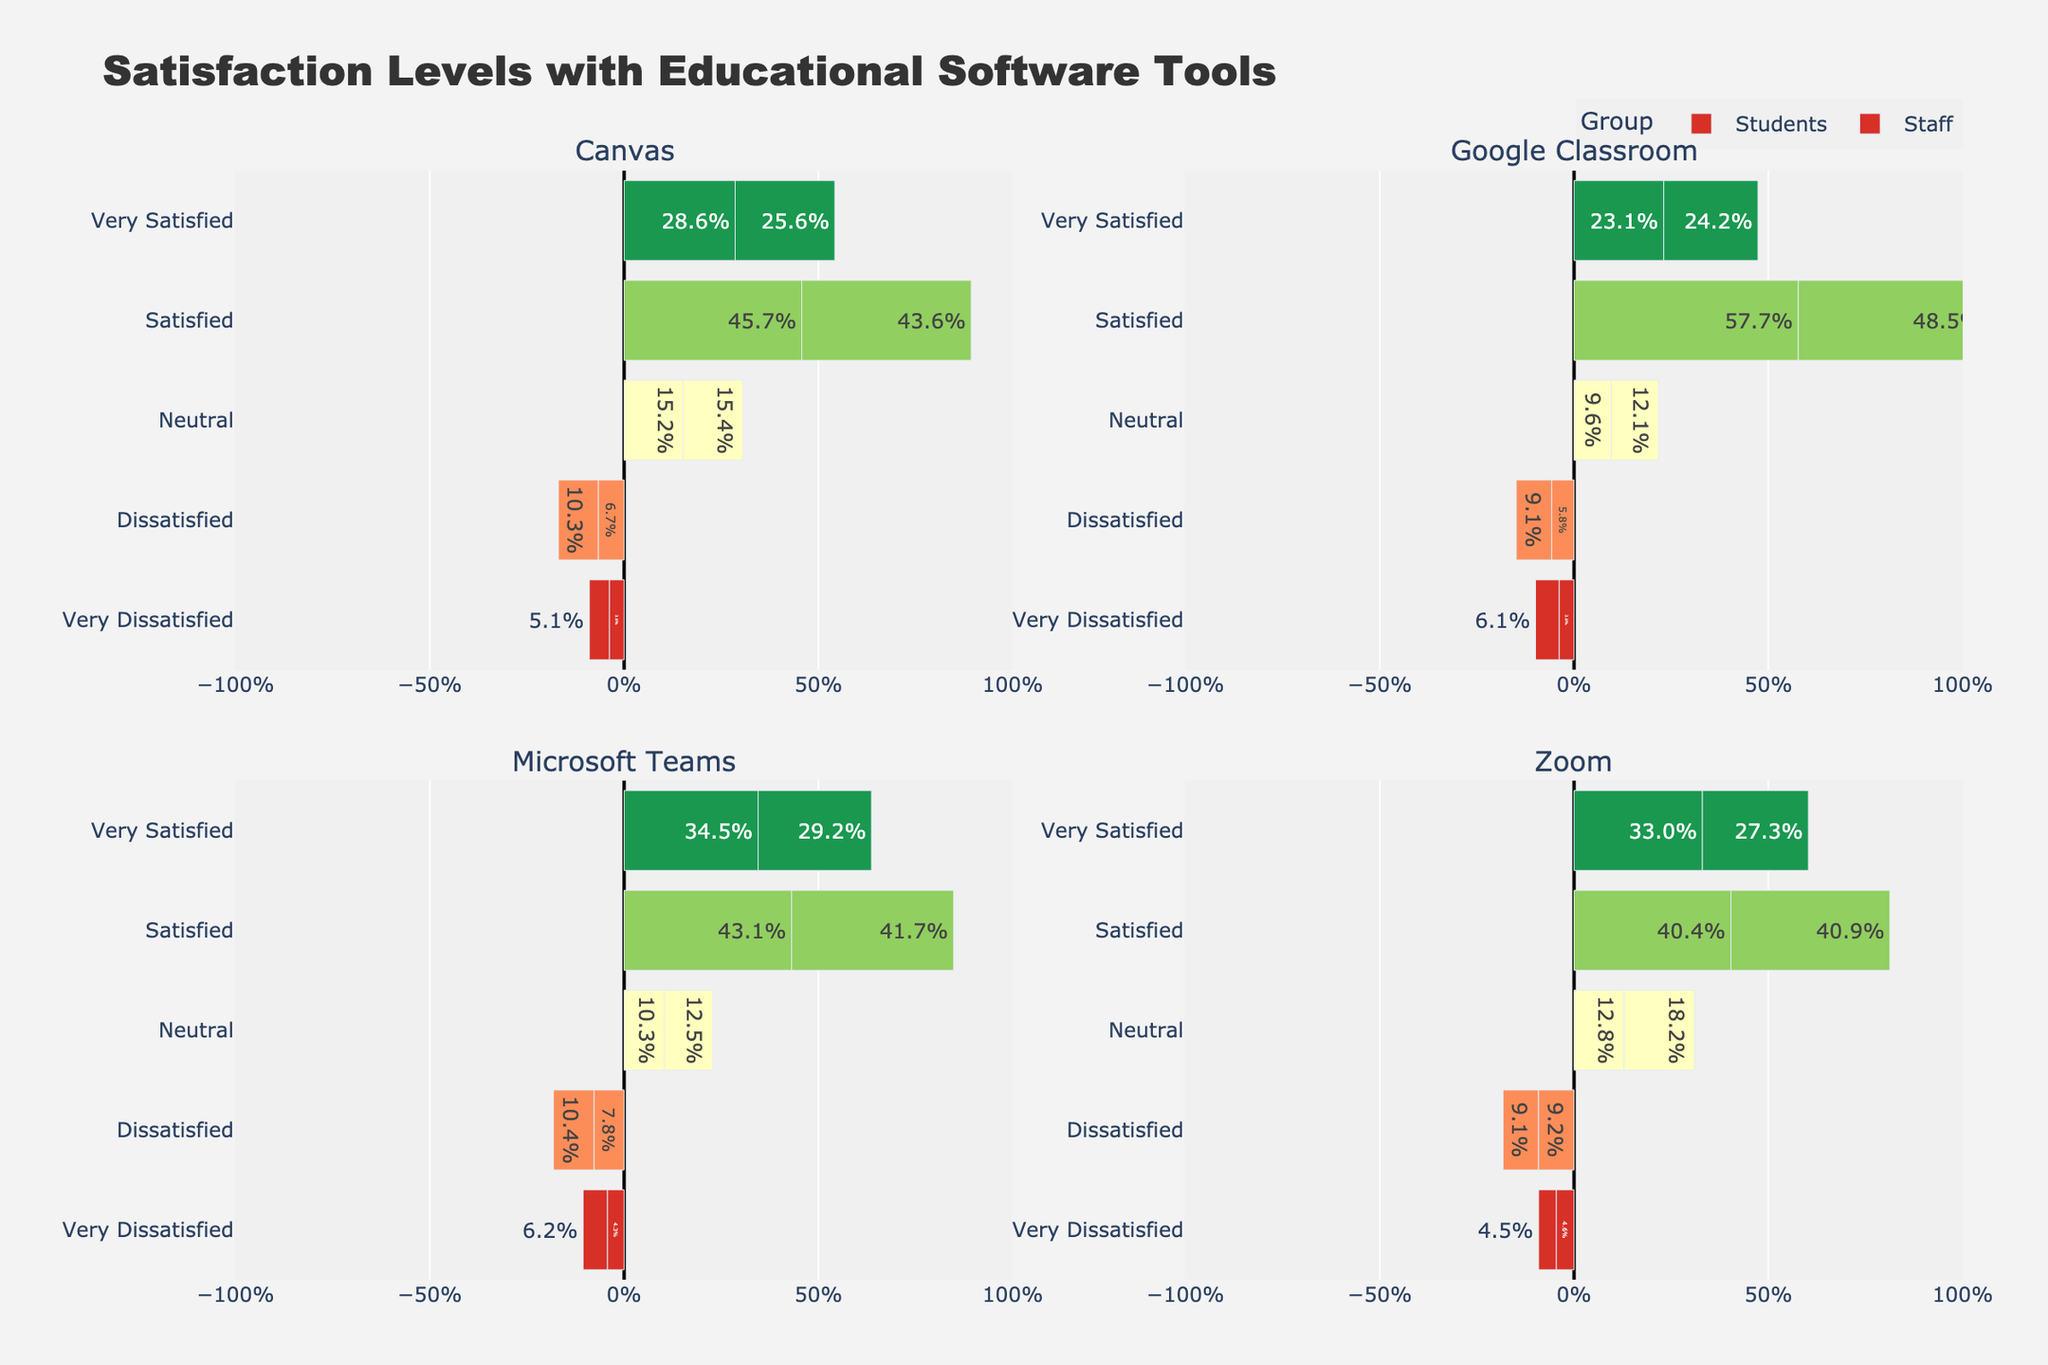What is the overall satisfaction (Very Satisfied + Satisfied) percentage for Students using Microsoft Teams? First, identify the counts for Very Satisfied and Satisfied for Students using Microsoft Teams: 200 and 250 respectively. The total count of responses from Students for Microsoft Teams is 200 + 250 + 60 + 45 + 25 = 580. So, the overall satisfaction percentage is ((200 + 250) / 580) * 100 = (450 / 580) * 100 ≈ 77.6%.
Answer: 77.6% Among the software tools, which one has the highest percentage of Staff being Very Satisfied? Check the bar lengths for Very Satisfied in each subplot for Staff. Microsoft Teams shows the highest percentage visually.
Answer: Microsoft Teams How do the satisfaction levels of Students compare between Google Classroom and Zoom? Compare the lengths and locations of the satisfaction level bars between the two subplots for Students. In general, Zoom has more Students that are Very Satisfied and Satisfied compared to Google Classroom.
Answer: Zoom has higher satisfaction levels Which group has a higher percentage of dissatisfaction (Dissatisfied + Very Dissatisfied) for Canvas? Compare the lengths of the Dissatisfied and Very Dissatisfied bars for both Students and Staff in the Canvas subplot. Students have a higher overall percentage of dissatisfaction.
Answer: Students Which software tool has the smallest proportion of Neutral responses for Staff? Examine the Neutral bars for Staff across all subplots. Microsoft Teams has the shortest Neutral bar for Staff.
Answer: Microsoft Teams How does the satisfaction of Staff compare between Zoom and Microsoft Teams? Look at the relative lengths of the satisfaction level bars for Staff in the Zoom and Microsoft Teams subplots. Microsoft Teams has longer bars for Very Satisfied and Satisfied compared to Zoom.
Answer: Microsoft Teams has higher satisfaction For Zoom, what is the percentage difference between Students and Staff in the Very Satisfied category? Calculate the percentage of Very Satisfied for both Students and Staff using their respective total counts: Students: (180 / 545) * 100 ≈ 33.0%, Staff: (60 / 220) * 100 ≈ 27.3%. The percentage difference is 33.0% - 27.3% ≈ 5.7%.
Answer: 5.7% Is the Neutral category more prevalent among Students or Staff for Google Classroom, and by how much? Calculate the percentage for the Neutral category for both groups: Students: (50 / 520) * 100 ≈ 9.6%, Staff: (20 / 165) * 100 ≈ 12.1%. Staff has 12.1% - 9.6% ≈ 2.5% more Neutral responses.
Answer: Staff by 2.5% 